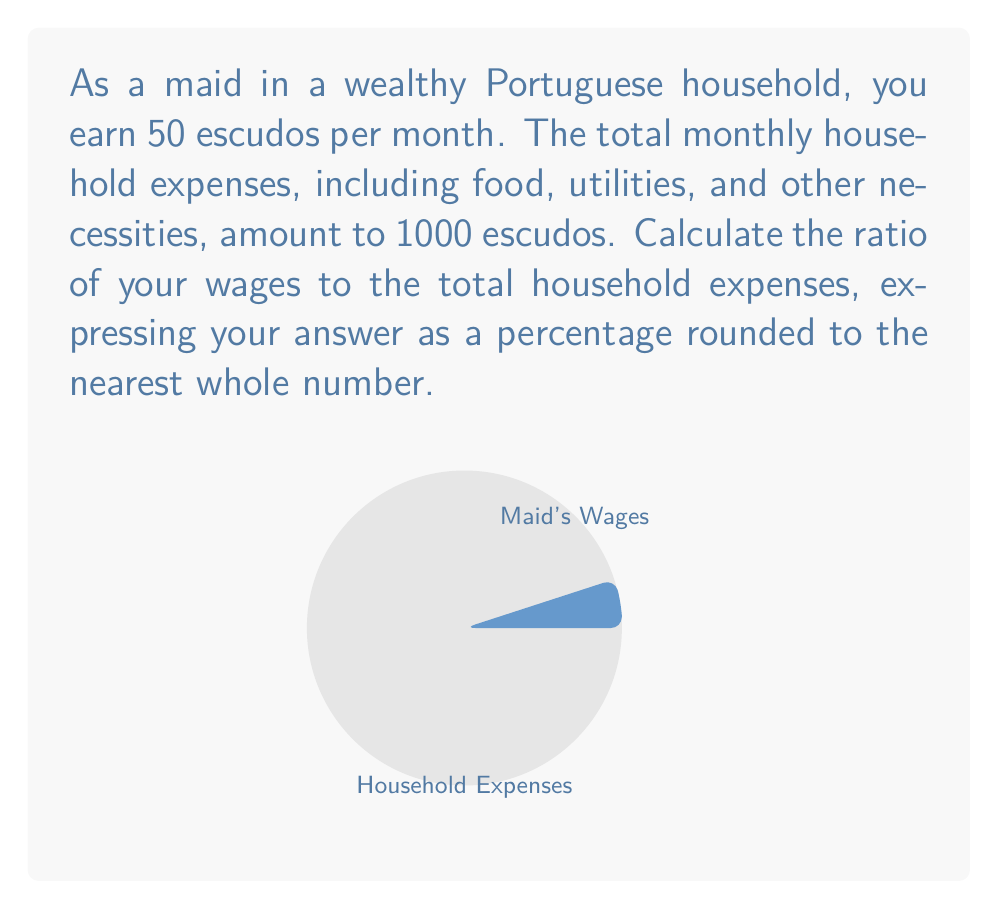Show me your answer to this math problem. To calculate the ratio of servant wages to household expenses as a percentage, we follow these steps:

1) First, let's identify our values:
   - Maid's wages: 50 escudos
   - Total household expenses: 1000 escudos

2) The ratio is calculated by dividing the maid's wages by the total household expenses:
   
   $$ \text{Ratio} = \frac{\text{Maid's wages}}{\text{Total household expenses}} $$

3) Plugging in our values:

   $$ \text{Ratio} = \frac{50}{1000} = 0.05 $$

4) To express this as a percentage, we multiply by 100:

   $$ \text{Percentage} = 0.05 \times 100 = 5\% $$

5) The question asks for the nearest whole number, but 5% is already a whole number, so no rounding is necessary.

Therefore, the maid's wages represent 5% of the total household expenses.
Answer: 5% 